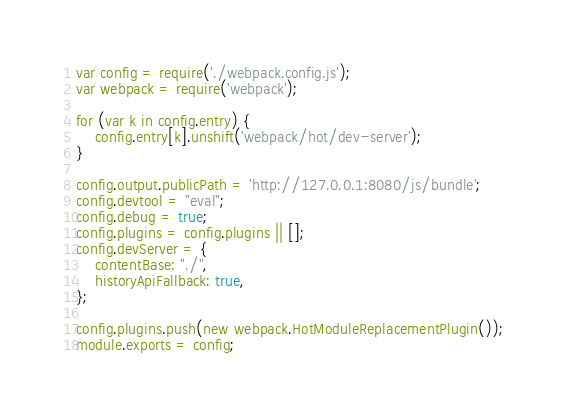Convert code to text. <code><loc_0><loc_0><loc_500><loc_500><_JavaScript_>var config = require('./webpack.config.js');
var webpack = require('webpack');

for (var k in config.entry) {
    config.entry[k].unshift('webpack/hot/dev-server');
}

config.output.publicPath = 'http://127.0.0.1:8080/js/bundle';
config.devtool = "eval";
config.debug = true;
config.plugins = config.plugins || [];
config.devServer = {
    contentBase: "./",
    historyApiFallback: true,
};

config.plugins.push(new webpack.HotModuleReplacementPlugin());
module.exports = config;
</code> 